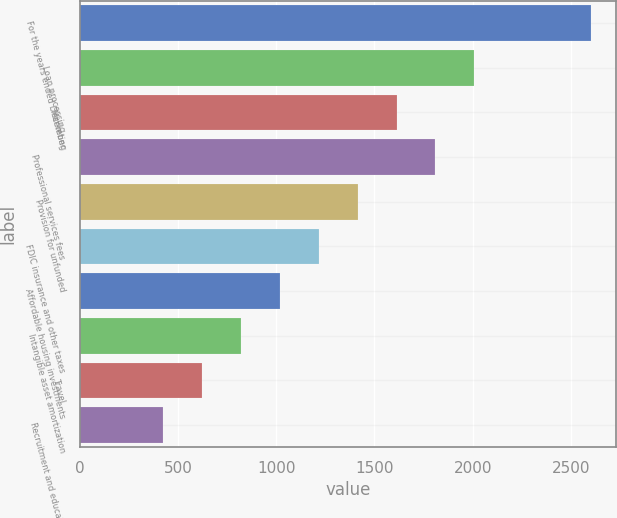<chart> <loc_0><loc_0><loc_500><loc_500><bar_chart><fcel>For the years ended December<fcel>Loan processing<fcel>Marketing<fcel>Professional services fees<fcel>Provision for unfunded<fcel>FDIC insurance and other taxes<fcel>Affordable housing investments<fcel>Intangible asset amortization<fcel>Travel<fcel>Recruitment and education<nl><fcel>2601.1<fcel>2008<fcel>1612.6<fcel>1810.3<fcel>1414.9<fcel>1217.2<fcel>1019.5<fcel>821.8<fcel>624.1<fcel>426.4<nl></chart> 